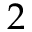Convert formula to latex. <formula><loc_0><loc_0><loc_500><loc_500>2</formula> 